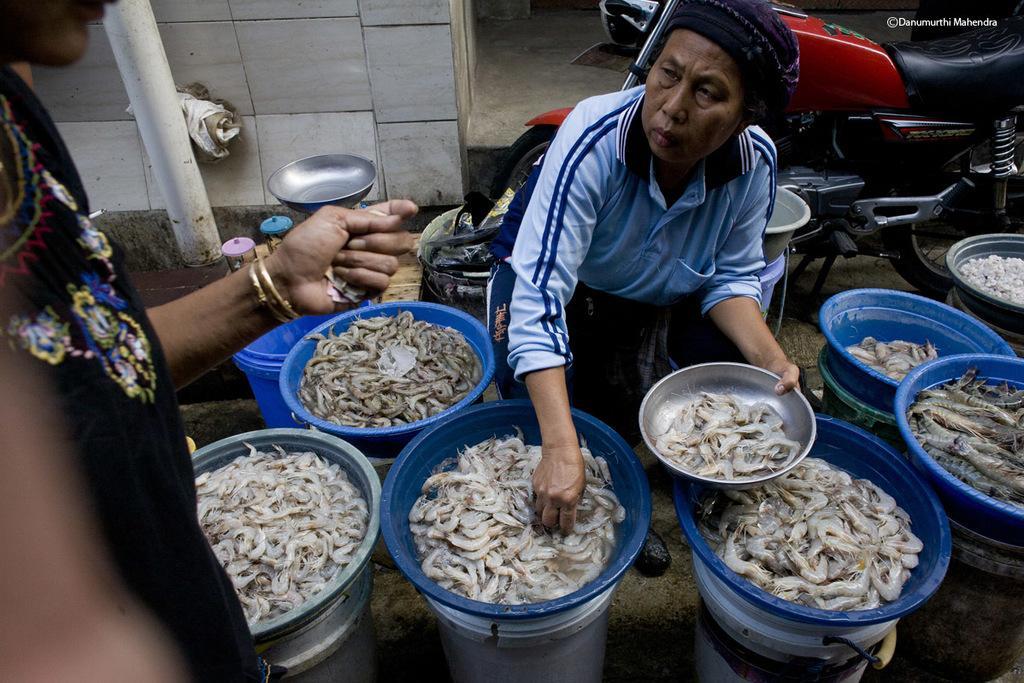Please provide a concise description of this image. On the left side of the image a person is standing. In the middle of the image a person is sitting and holding a bowl and there are some some bowls, in the bowels there are some prawns. Behind the person there is a motorcycle and wall. 